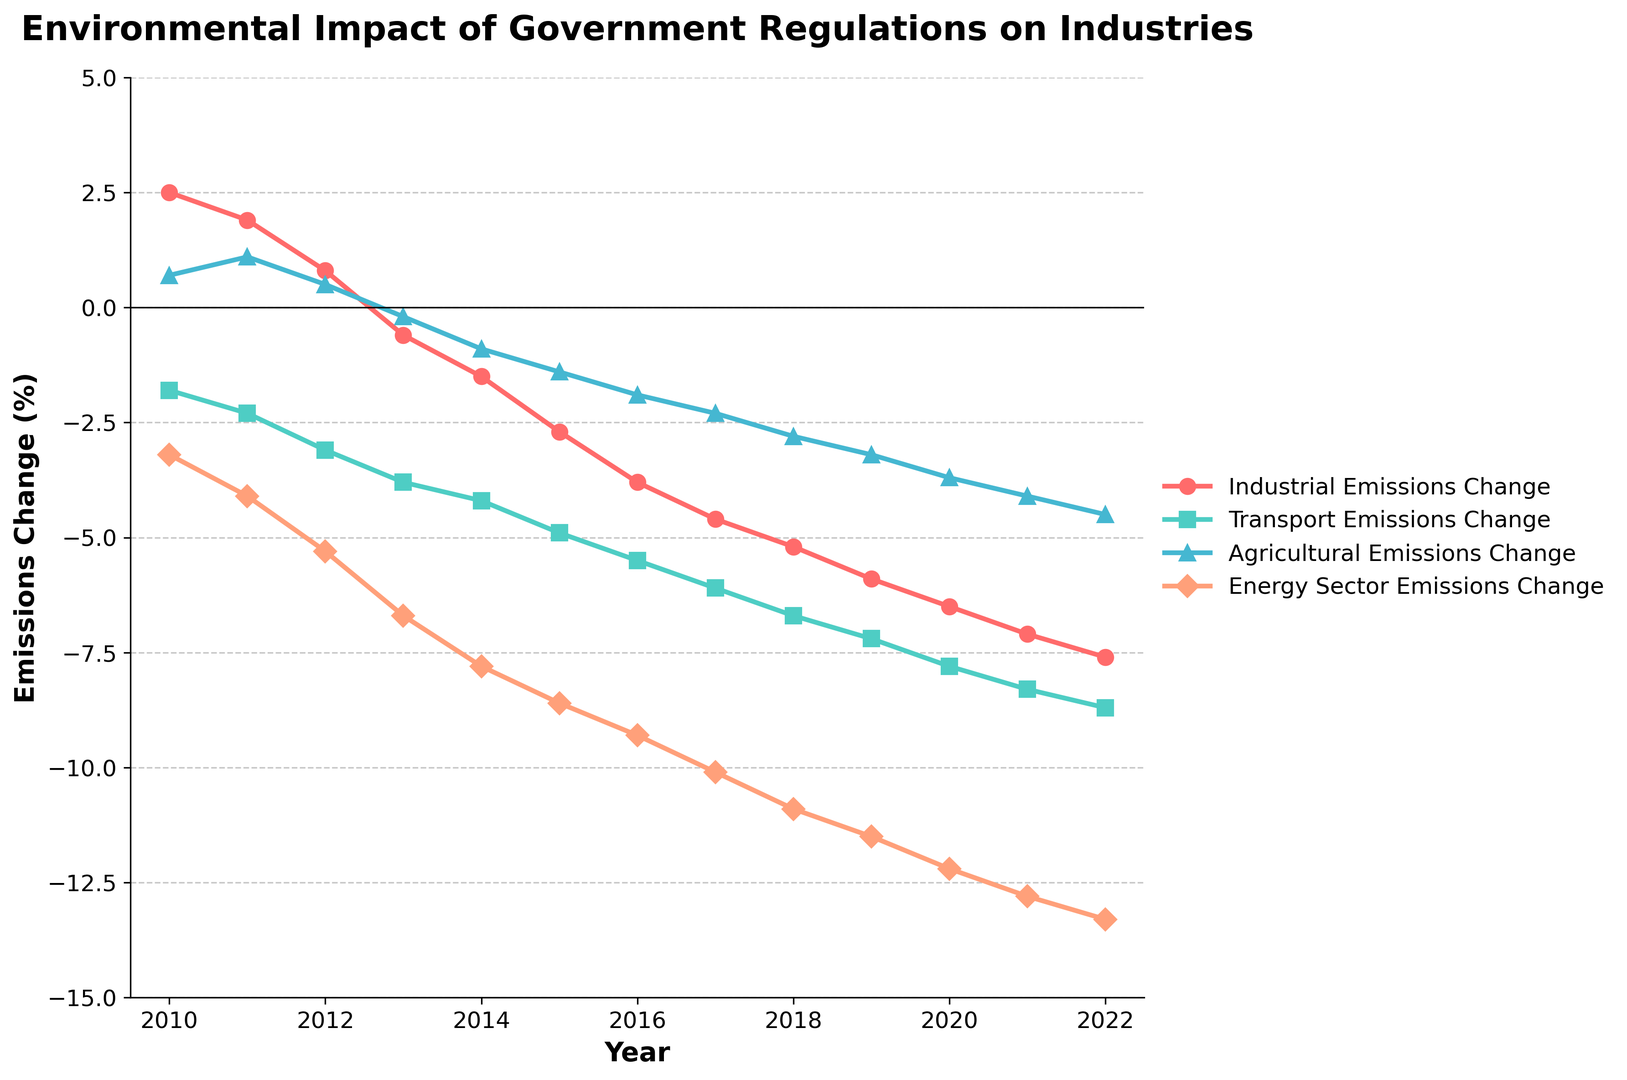Which sector showed the steepest decline in emissions from 2010 to 2022? To identify the sector with the steepest decline, look for the line with the greatest negative slope from 2010 to 2022. In the plot, the Energy Sector Emissions Change shows the steepest decline.
Answer: Energy Sector What is the difference in transport emissions change between 2013 and 2019? Find the emissions change for Transport in 2013 and 2019 from the chart, which are approximately -3.8% and -7.2%, respectively. The difference is -7.2 - (-3.8) = -3.4.
Answer: -3.4% Which year did the Industrial Emissions Change first record a negative value? Check the plotted line for Industrial Emissions Change and identify the year it crosses the zero line into negative territory. This first occurs in 2013.
Answer: 2013 How did Agricultural Emissions Change behave from 2015 to 2022? Observe the plotted line for Agricultural Emissions Change from 2015 to 2022. It declines steadily, starting from roughly -1.4% in 2015 to about -4.5% in 2022.
Answer: Steadily declined Which sectors experienced an overall decline in emissions from 2010 to 2022? Look at the overall trend of each sector's line from 2010 to 2022. All sectors (Industrial, Transport, Agricultural, Energy) show a downward trend throughout the period.
Answer: All sectors In which year did the Energy Sector Emissions Change drop below -10%? Find the point on the Energy Sector Emissions Change plotted line where it first goes below -10%. This occurs in the year 2017.
Answer: 2017 Between Industrial Emissions Change and Transport Emissions Change, which had a greater reduction in 2015? Compare the values for Industrial Emissions Change and Transport Emissions Change in 2015, which are approximately -2.7% and -4.9%, respectively. The greater reduction is in Transport Emissions Change.
Answer: Transport Emissions Change What is the total change in Agricultural Emissions from 2010 to 2022? Add the changes in Agricultural Emissions from 2010 to 2022. The values are (0.7 + 1.1 + 0.5 - 0.2 - 0.9 - 1.4 - 1.9 - 2.3 - 2.8 - 3.2 - 3.7 - 4.1 - 4.5), which sum up to -22.7%.
Answer: -22.7% Which sector showed the least amount of change in emissions in 2022? Compare the values of emissions change for all sectors in 2022 and identify the smallest magnitude of change. The Industrial Emissions Change at around -7.6% is the least among the sectors.
Answer: Industrial Emissions What color represents the Energy Sector Emissions Change in the chart? Identify the color of the line that represents Energy Sector Emissions Change. It is depicted in salmon.
Answer: Salmon 